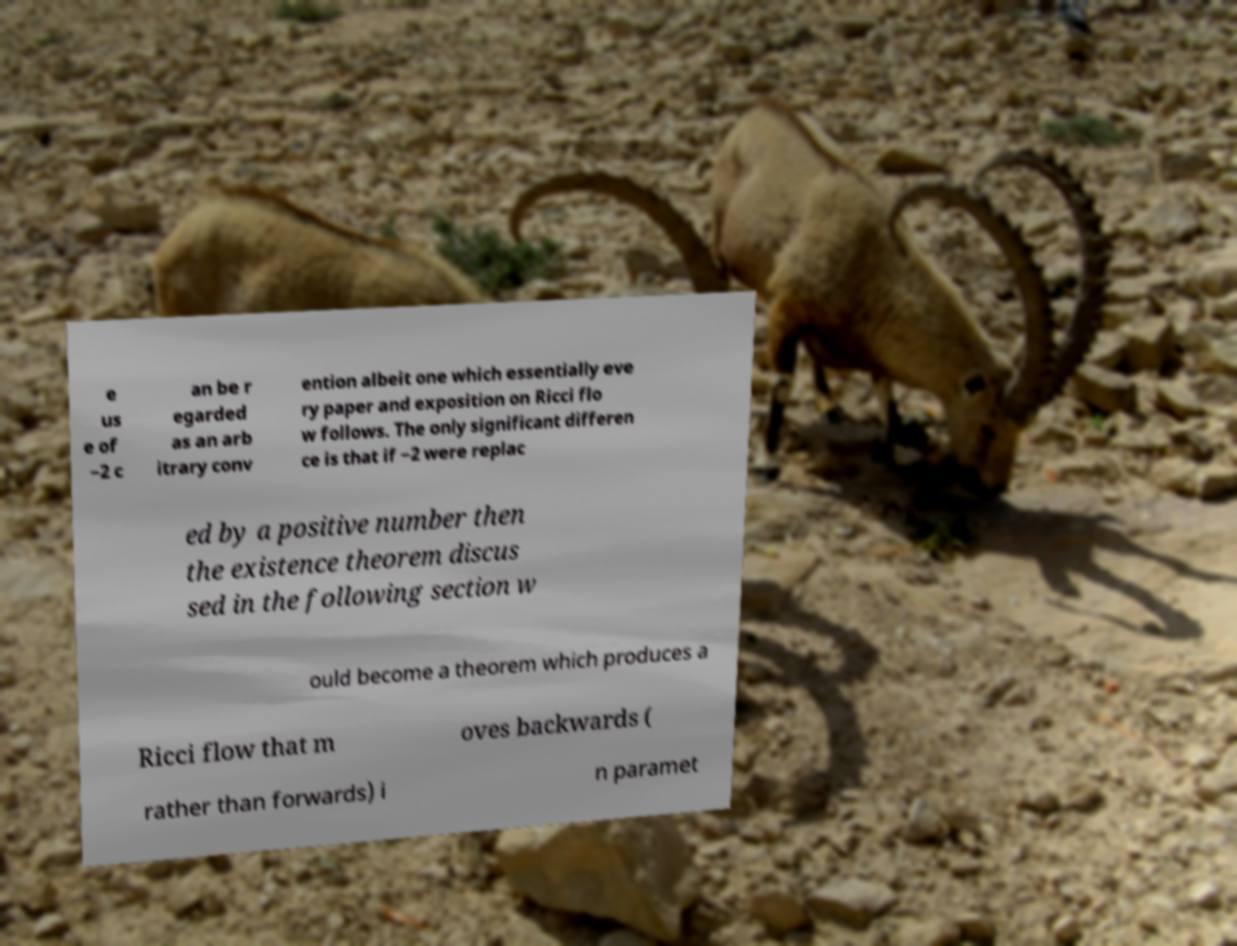Could you extract and type out the text from this image? e us e of −2 c an be r egarded as an arb itrary conv ention albeit one which essentially eve ry paper and exposition on Ricci flo w follows. The only significant differen ce is that if −2 were replac ed by a positive number then the existence theorem discus sed in the following section w ould become a theorem which produces a Ricci flow that m oves backwards ( rather than forwards) i n paramet 